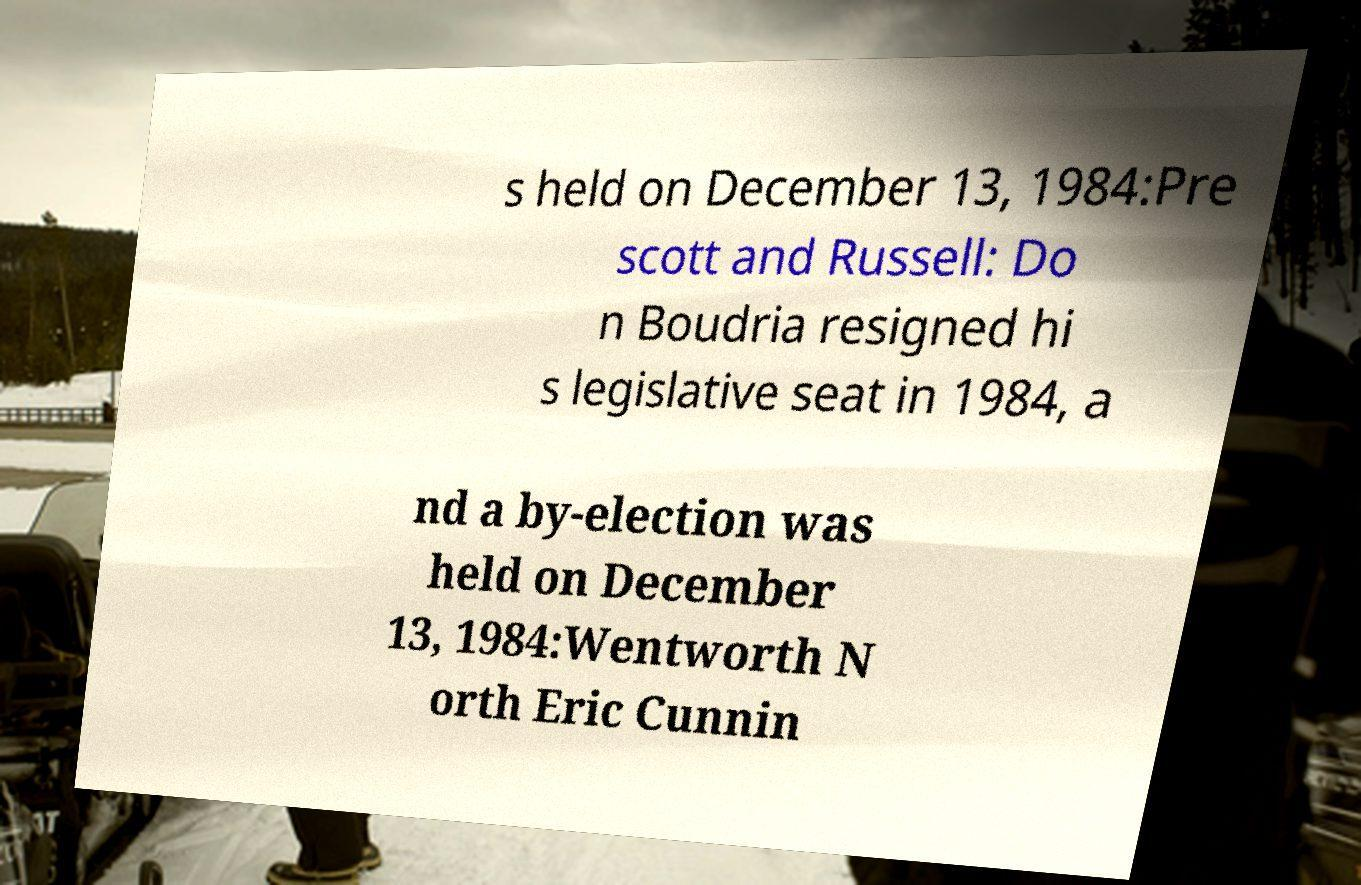Could you extract and type out the text from this image? s held on December 13, 1984:Pre scott and Russell: Do n Boudria resigned hi s legislative seat in 1984, a nd a by-election was held on December 13, 1984:Wentworth N orth Eric Cunnin 